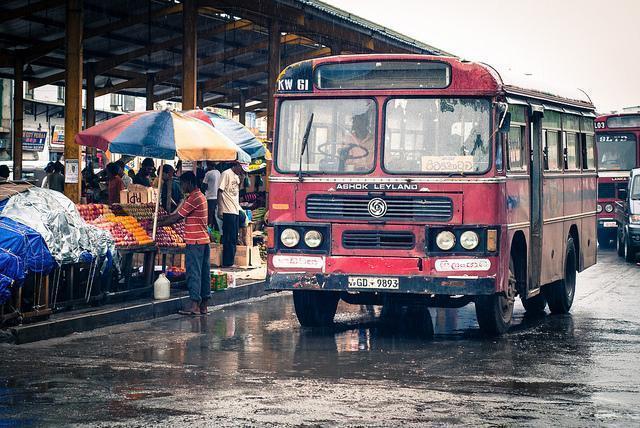What food can you buy as you get on the bus?
From the following set of four choices, select the accurate answer to respond to the question.
Options: Bread, steak, fish, fruit. Fruit. 